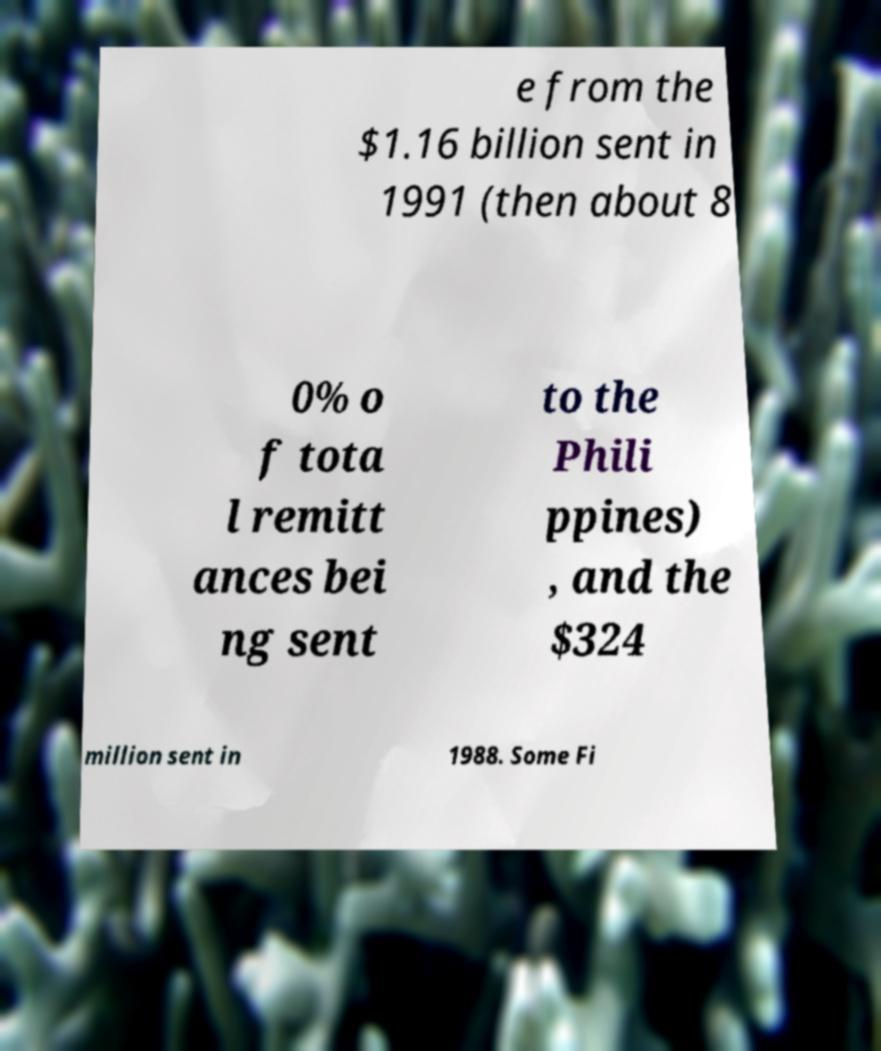Can you accurately transcribe the text from the provided image for me? e from the $1.16 billion sent in 1991 (then about 8 0% o f tota l remitt ances bei ng sent to the Phili ppines) , and the $324 million sent in 1988. Some Fi 